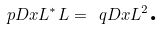Convert formula to latex. <formula><loc_0><loc_0><loc_500><loc_500>\ p D x { L ^ { * } L } = \ q D x { L } ^ { 2 } \text {.}</formula> 